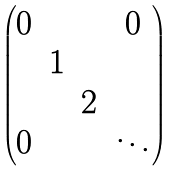<formula> <loc_0><loc_0><loc_500><loc_500>\begin{pmatrix} 0 & & & 0 \\ & 1 & & \\ & & 2 & \\ 0 & & & \ddots \end{pmatrix}</formula> 